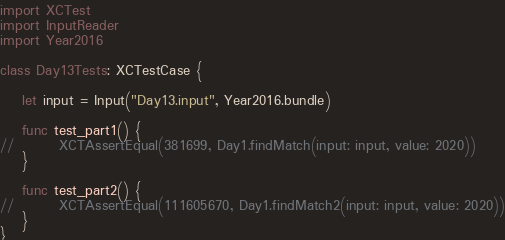Convert code to text. <code><loc_0><loc_0><loc_500><loc_500><_Swift_>import XCTest
import InputReader
import Year2016

class Day13Tests: XCTestCase {
    
    let input = Input("Day13.input", Year2016.bundle)

    func test_part1() {
//        XCTAssertEqual(381699, Day1.findMatch(input: input, value: 2020))
    }
    
    func test_part2() {
//        XCTAssertEqual(111605670, Day1.findMatch2(input: input, value: 2020))
    }
}
</code> 